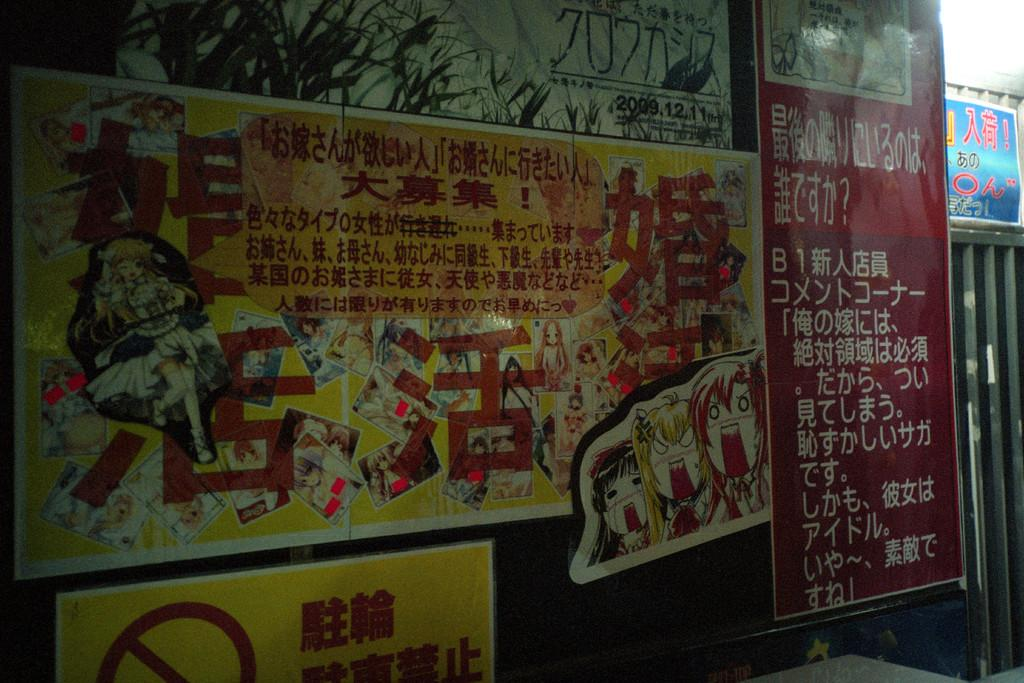What is the main object in the image with images and text? There is a board with images and text in the image. What type of structure can be seen in the image? There is a metal structure in the image. What is written on the banner above the metal structure? The banner with text is above the metal structure, but the specific text is not mentioned in the facts. Can you describe the metal structure in the image? The facts only mention that there is a metal structure in the image, but no further details are provided. How many sheep are visible in the image? There are no sheep present in the image. What type of voyage is depicted in the image? There is no voyage depicted in the image; it features a board with images and text, a metal structure, and a banner with text. 